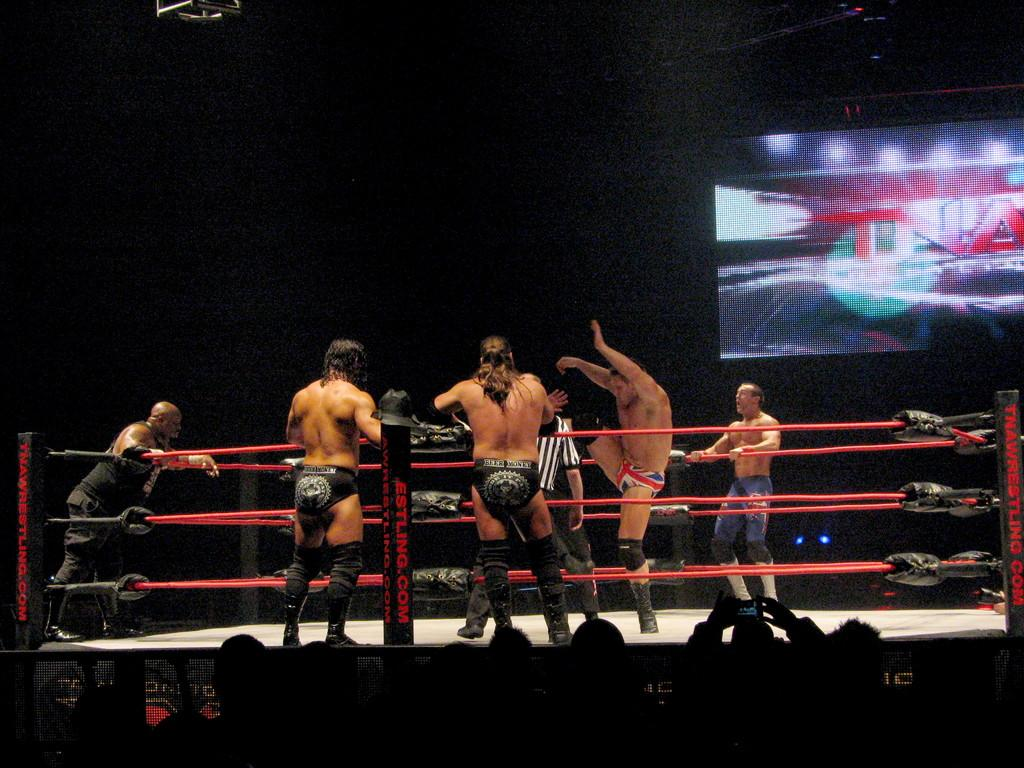<image>
Offer a succinct explanation of the picture presented. A group of TNA wrestlers stand around a ring watching some wrestling. 